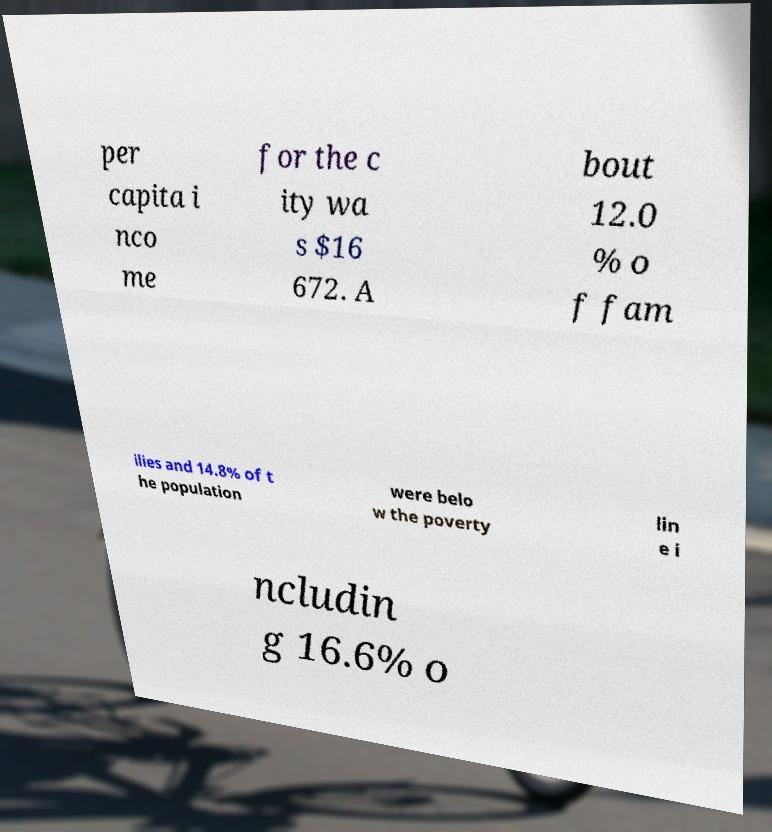Please identify and transcribe the text found in this image. per capita i nco me for the c ity wa s $16 672. A bout 12.0 % o f fam ilies and 14.8% of t he population were belo w the poverty lin e i ncludin g 16.6% o 